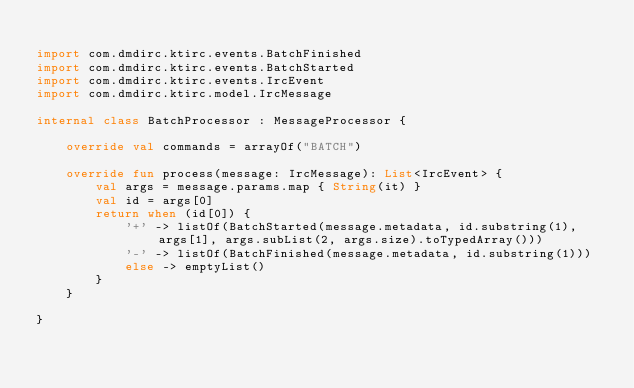Convert code to text. <code><loc_0><loc_0><loc_500><loc_500><_Kotlin_>
import com.dmdirc.ktirc.events.BatchFinished
import com.dmdirc.ktirc.events.BatchStarted
import com.dmdirc.ktirc.events.IrcEvent
import com.dmdirc.ktirc.model.IrcMessage

internal class BatchProcessor : MessageProcessor {

    override val commands = arrayOf("BATCH")

    override fun process(message: IrcMessage): List<IrcEvent> {
        val args = message.params.map { String(it) }
        val id = args[0]
        return when (id[0]) {
            '+' -> listOf(BatchStarted(message.metadata, id.substring(1), args[1], args.subList(2, args.size).toTypedArray()))
            '-' -> listOf(BatchFinished(message.metadata, id.substring(1)))
            else -> emptyList()
        }
    }

}
</code> 